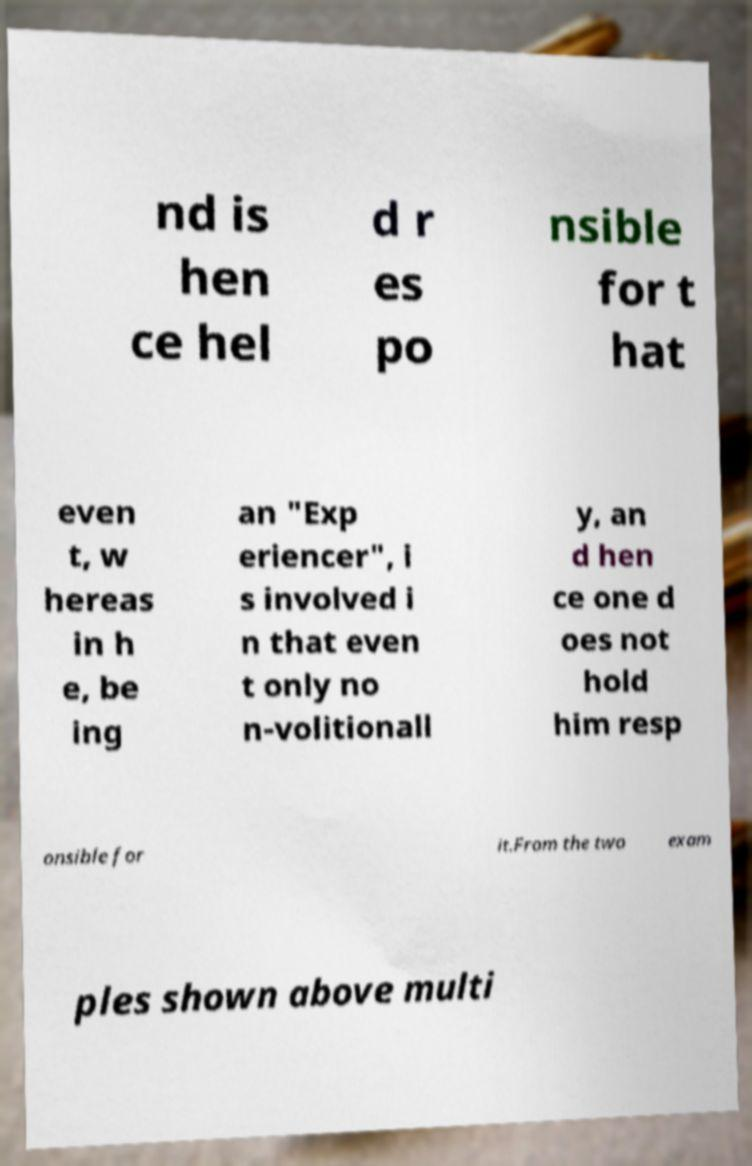Can you read and provide the text displayed in the image?This photo seems to have some interesting text. Can you extract and type it out for me? nd is hen ce hel d r es po nsible for t hat even t, w hereas in h e, be ing an "Exp eriencer", i s involved i n that even t only no n-volitionall y, an d hen ce one d oes not hold him resp onsible for it.From the two exam ples shown above multi 